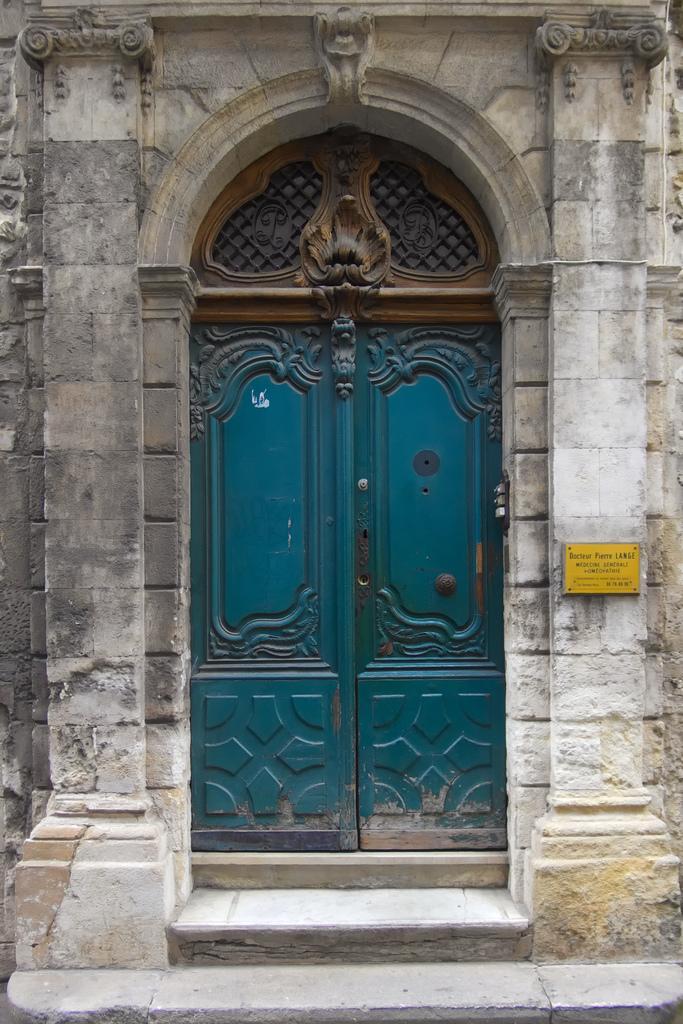In one or two sentences, can you explain what this image depicts? In this picture we can see doors, here we can see a name board on the wall. 